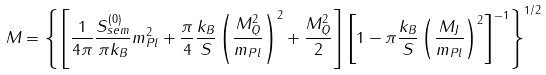Convert formula to latex. <formula><loc_0><loc_0><loc_500><loc_500>M = \left \{ \left [ \frac { 1 } { 4 \pi } \frac { S _ { s e m } ^ { ( 0 ) } } { \pi k _ { B } } m ^ { 2 } _ { P l } + \frac { \pi } { 4 } \frac { k _ { B } } { S } \left ( \frac { M _ { Q } ^ { 2 } } { m _ { P l } } \right ) ^ { 2 } + \frac { M _ { Q } ^ { 2 } } { 2 } \right ] \left [ 1 - \pi \frac { k _ { B } } { S } \left ( \frac { M _ { J } } { m _ { P l } } \right ) ^ { 2 } \right ] ^ { - 1 } \right \} ^ { 1 / 2 }</formula> 